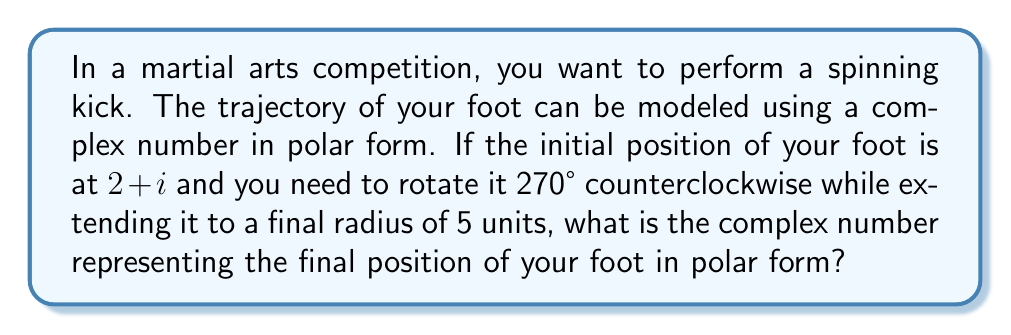Can you solve this math problem? Let's approach this step-by-step:

1) First, we need to convert the initial position $2+i$ to polar form.

   $r = \sqrt{2^2 + 1^2} = \sqrt{5}$
   $\theta = \tan^{-1}(\frac{1}{2}) \approx 0.4636$ radians or $26.57°$

   So, $2+i = \sqrt{5}(\cos(0.4636) + i\sin(0.4636))$

2) Now, we need to rotate this by 270° counterclockwise. In radians, this is:
   
   $270° \times \frac{\pi}{180°} = \frac{3\pi}{2}$ radians

3) The new angle will be:

   $0.4636 + \frac{3\pi}{2} = 5.1760$ radians

4) We're also told that the final radius should be 5 units.

5) Therefore, the final position in polar form will be:

   $5(\cos(5.1760) + i\sin(5.1760))$

6) This can be written more compactly as:

   $5e^{5.1760i}$

This represents the optimal trajectory for the spinning kick in polar form.
Answer: $5e^{5.1760i}$ 